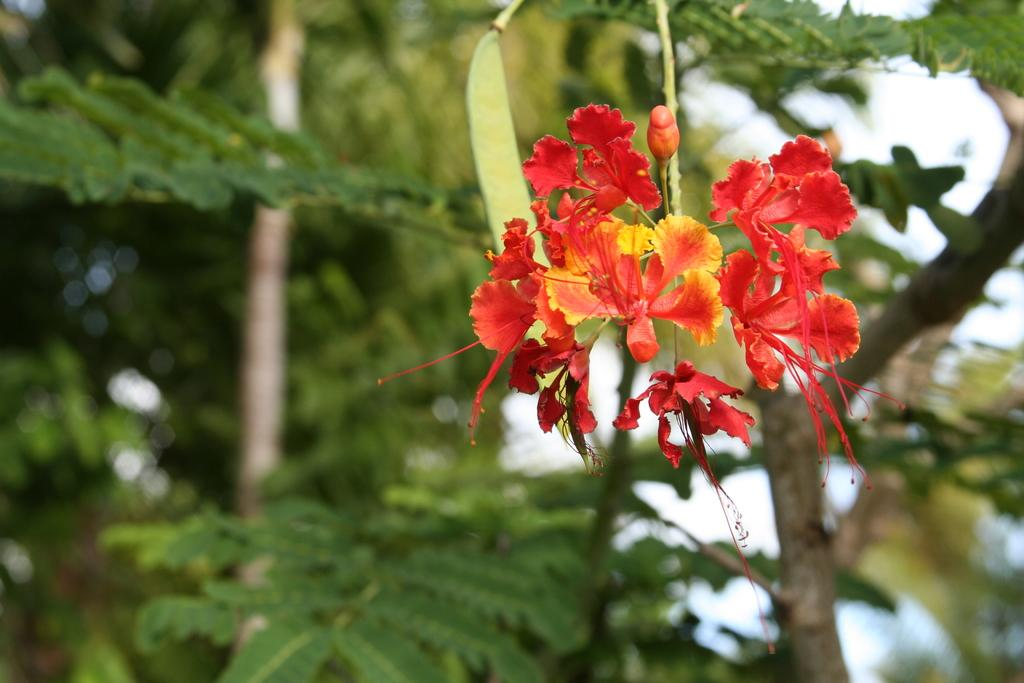What is the main subject in the middle of the image? There are flowers in the middle of the image. What can be seen in the background of the image? There are trees in the background of the image. What type of boat is visible in the image? There is no boat present in the image; it features flowers and trees. What emotion is being expressed by the flowers in the image? Flowers do not express emotions, so it is not possible to determine the emotion being expressed in the image. 